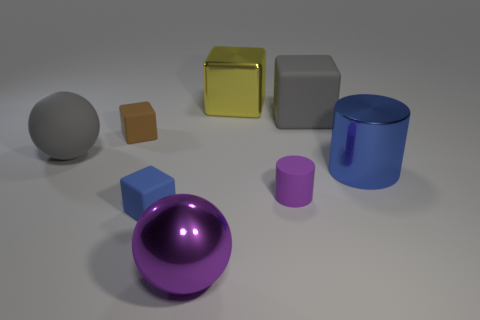There is a gray object that is the same shape as the yellow metallic object; what is its size?
Offer a terse response. Large. How many tiny blue matte objects are in front of the blue object that is in front of the blue cylinder?
Your answer should be compact. 0. Do the small thing that is on the right side of the large purple object and the blue object in front of the tiny purple thing have the same material?
Ensure brevity in your answer.  Yes. What number of other things are the same shape as the small blue thing?
Offer a terse response. 3. What number of tiny cylinders have the same color as the large shiny cube?
Give a very brief answer. 0. Is the shape of the blue thing that is on the left side of the large metal cylinder the same as the big gray thing that is to the left of the shiny block?
Your response must be concise. No. There is a gray rubber ball that is in front of the gray matte thing behind the brown rubber cube; what number of gray balls are in front of it?
Keep it short and to the point. 0. What material is the block behind the large gray object right of the big matte sphere to the left of the metallic cube made of?
Give a very brief answer. Metal. Do the big ball that is behind the big blue shiny cylinder and the gray block have the same material?
Ensure brevity in your answer.  Yes. What number of red blocks are the same size as the purple ball?
Provide a short and direct response. 0. 